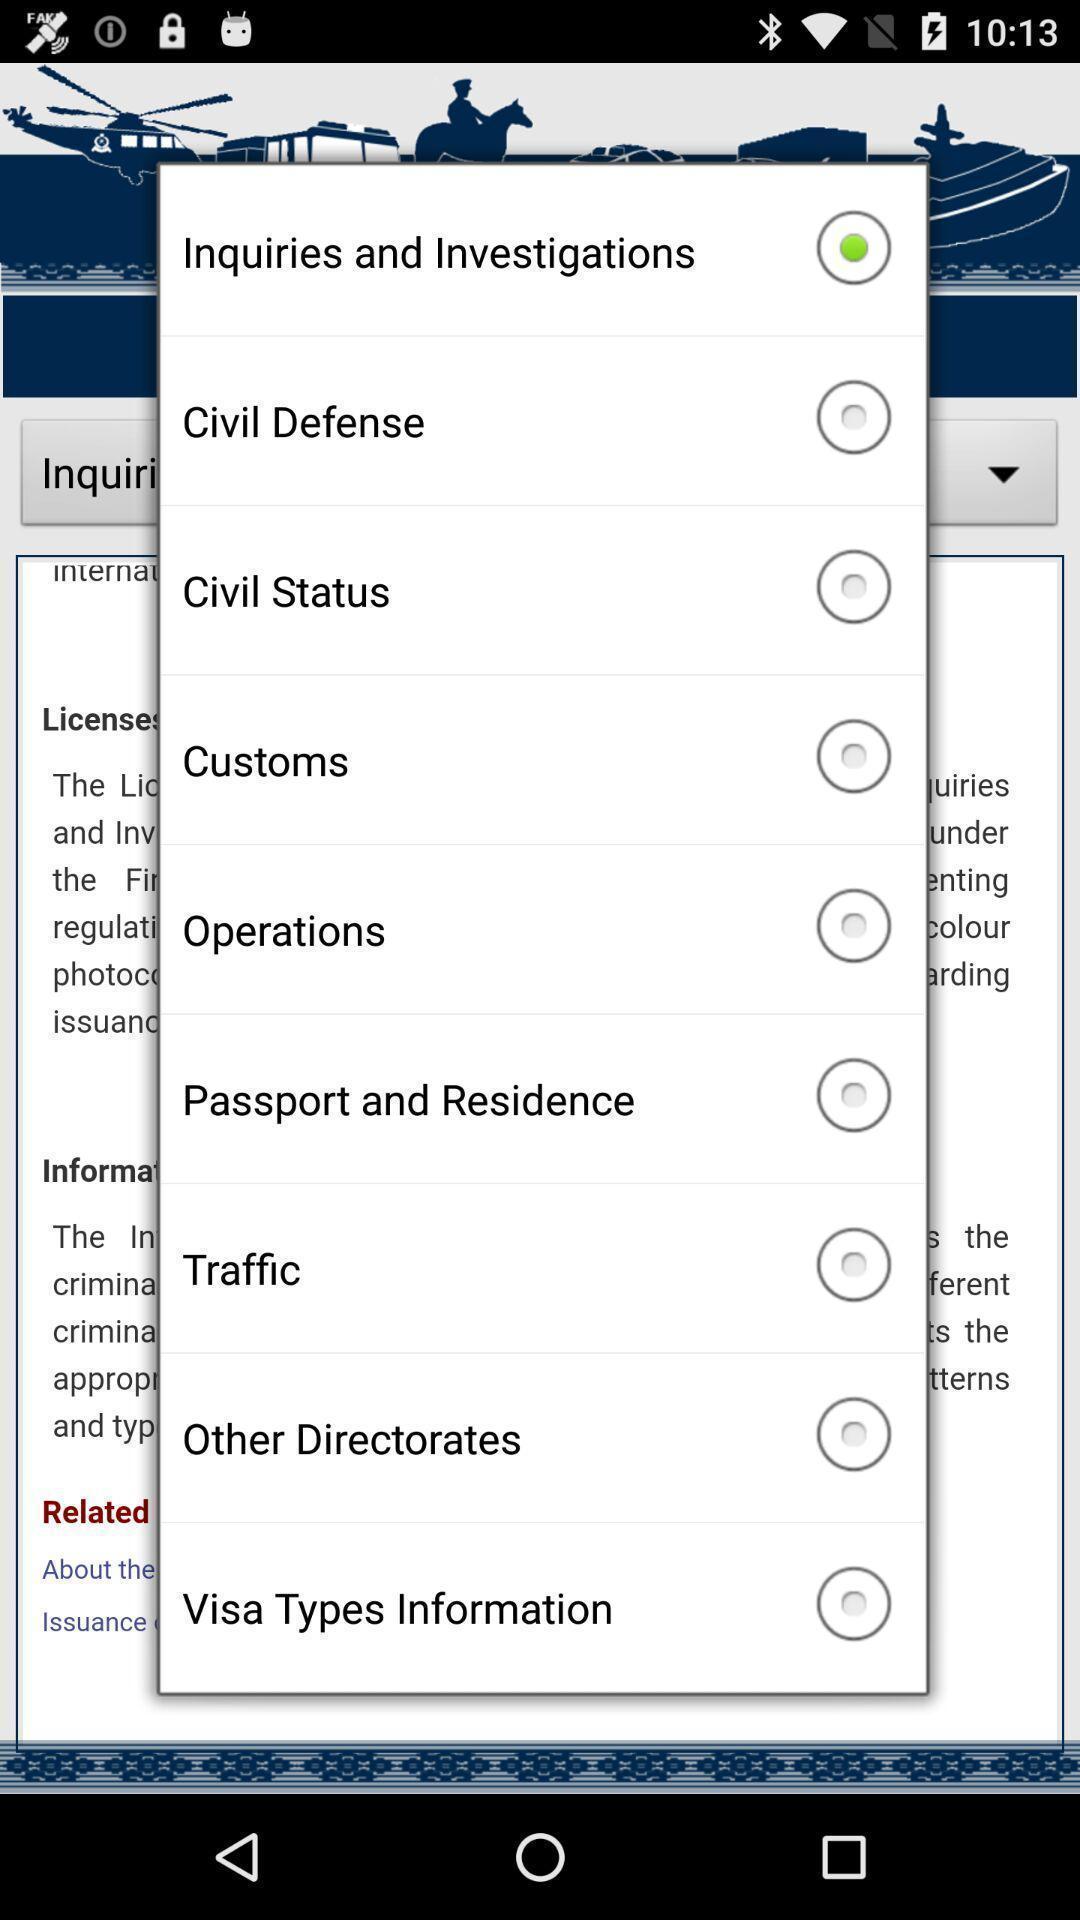Describe the key features of this screenshot. Pop-up with list of options on app. 